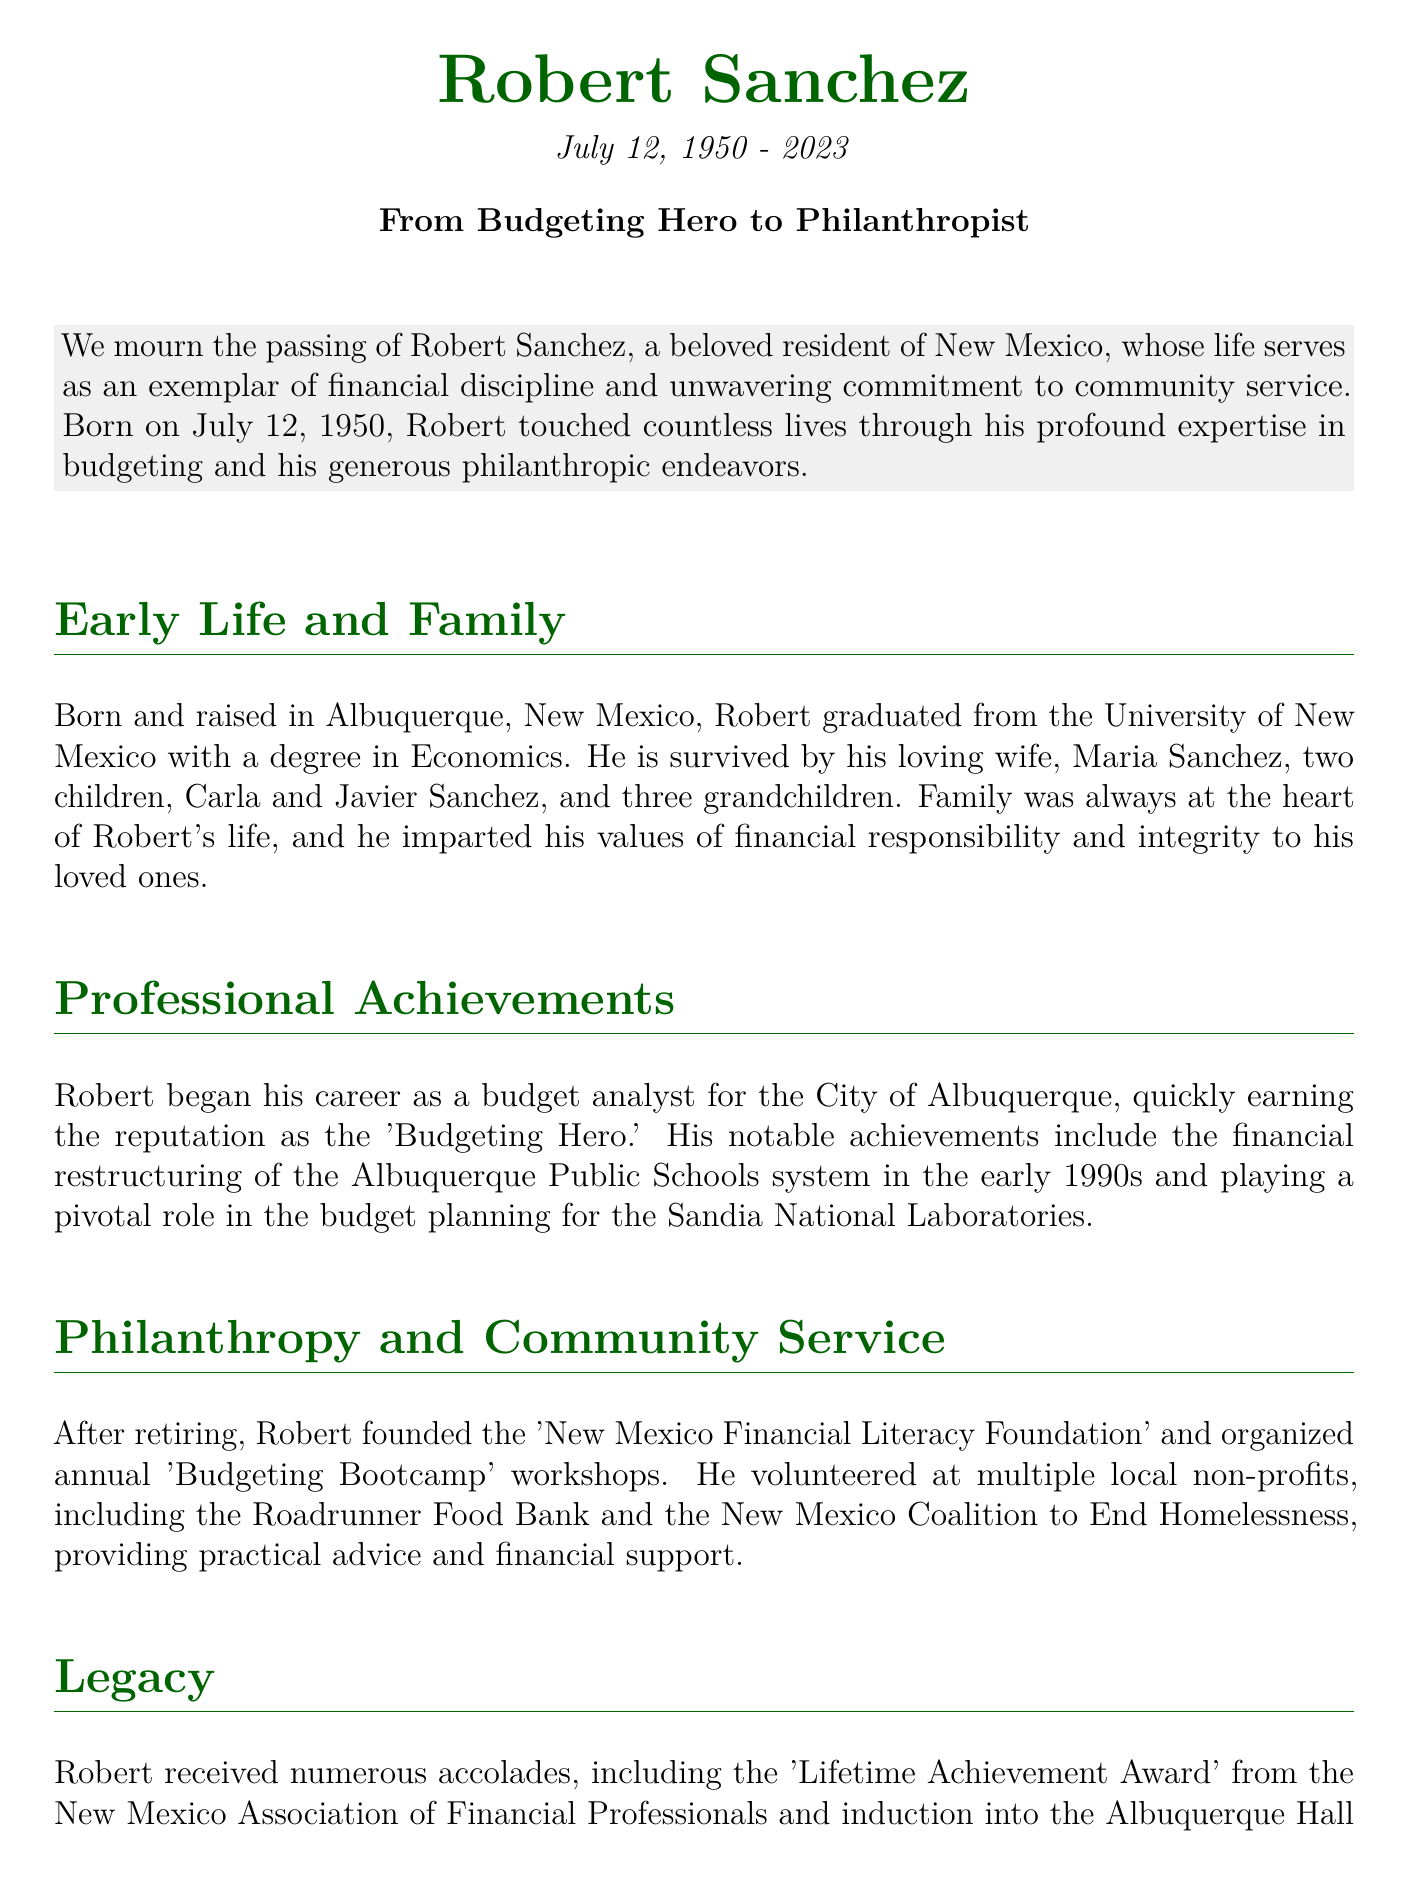what is Robert Sanchez's birth date? The document states Robert Sanchez was born on July 12, 1950.
Answer: July 12, 1950 where did Robert graduate from? The document mentions that Robert graduated from the University of New Mexico.
Answer: University of New Mexico what was Robert’s profession before retirement? The document describes Robert as a budget analyst for the City of Albuquerque.
Answer: budget analyst what foundation did Robert Sanchez found? The document states he founded the 'New Mexico Financial Literacy Foundation'.
Answer: New Mexico Financial Literacy Foundation how many children did Robert have? The document mentions Robert had two children, Carla and Javier Sanchez.
Answer: two what major achievement did Robert accomplish in the 1990s? The document notes he was involved in the financial restructuring of the Albuquerque Public Schools system.
Answer: financial restructuring of the Albuquerque Public Schools system what type of workshops did Robert organize? The document indicates he organized 'Budgeting Bootcamp' workshops.
Answer: Budgeting Bootcamp which award did Robert receive from the New Mexico Association of Financial Professionals? The document states he received the 'Lifetime Achievement Award'.
Answer: Lifetime Achievement Award how many grandchildren did Robert have? The document mentions he had three grandchildren.
Answer: three 